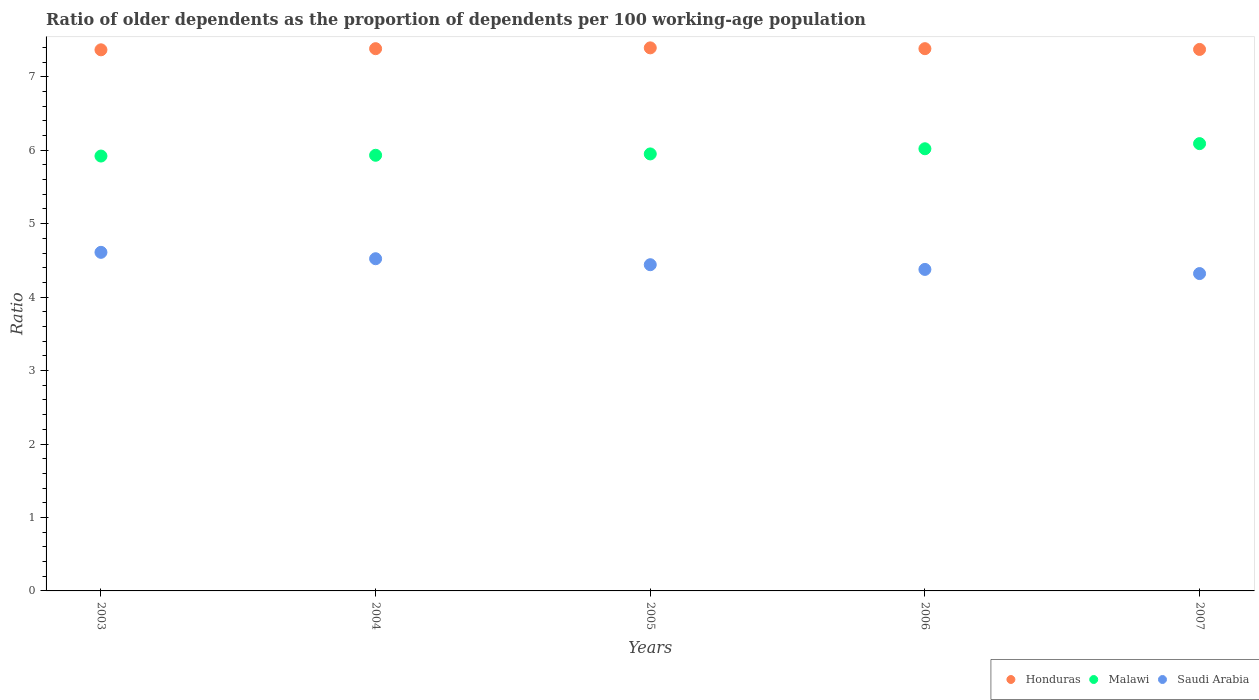What is the age dependency ratio(old) in Malawi in 2005?
Ensure brevity in your answer.  5.95. Across all years, what is the maximum age dependency ratio(old) in Honduras?
Give a very brief answer. 7.39. Across all years, what is the minimum age dependency ratio(old) in Saudi Arabia?
Keep it short and to the point. 4.32. In which year was the age dependency ratio(old) in Malawi minimum?
Your answer should be very brief. 2003. What is the total age dependency ratio(old) in Honduras in the graph?
Offer a very short reply. 36.9. What is the difference between the age dependency ratio(old) in Saudi Arabia in 2003 and that in 2004?
Offer a very short reply. 0.09. What is the difference between the age dependency ratio(old) in Malawi in 2004 and the age dependency ratio(old) in Saudi Arabia in 2007?
Keep it short and to the point. 1.61. What is the average age dependency ratio(old) in Malawi per year?
Keep it short and to the point. 5.98. In the year 2003, what is the difference between the age dependency ratio(old) in Malawi and age dependency ratio(old) in Honduras?
Your answer should be compact. -1.45. In how many years, is the age dependency ratio(old) in Saudi Arabia greater than 3.8?
Ensure brevity in your answer.  5. What is the ratio of the age dependency ratio(old) in Honduras in 2004 to that in 2007?
Your answer should be very brief. 1. Is the age dependency ratio(old) in Honduras in 2003 less than that in 2007?
Ensure brevity in your answer.  Yes. What is the difference between the highest and the second highest age dependency ratio(old) in Malawi?
Make the answer very short. 0.07. What is the difference between the highest and the lowest age dependency ratio(old) in Malawi?
Your answer should be very brief. 0.17. In how many years, is the age dependency ratio(old) in Malawi greater than the average age dependency ratio(old) in Malawi taken over all years?
Make the answer very short. 2. Is it the case that in every year, the sum of the age dependency ratio(old) in Saudi Arabia and age dependency ratio(old) in Honduras  is greater than the age dependency ratio(old) in Malawi?
Offer a very short reply. Yes. Does the age dependency ratio(old) in Honduras monotonically increase over the years?
Your answer should be very brief. No. How many years are there in the graph?
Provide a succinct answer. 5. Are the values on the major ticks of Y-axis written in scientific E-notation?
Provide a short and direct response. No. What is the title of the graph?
Provide a short and direct response. Ratio of older dependents as the proportion of dependents per 100 working-age population. What is the label or title of the Y-axis?
Offer a terse response. Ratio. What is the Ratio of Honduras in 2003?
Offer a very short reply. 7.37. What is the Ratio in Malawi in 2003?
Give a very brief answer. 5.92. What is the Ratio of Saudi Arabia in 2003?
Your response must be concise. 4.61. What is the Ratio in Honduras in 2004?
Provide a succinct answer. 7.38. What is the Ratio in Malawi in 2004?
Offer a very short reply. 5.93. What is the Ratio in Saudi Arabia in 2004?
Keep it short and to the point. 4.52. What is the Ratio of Honduras in 2005?
Your response must be concise. 7.39. What is the Ratio of Malawi in 2005?
Make the answer very short. 5.95. What is the Ratio in Saudi Arabia in 2005?
Keep it short and to the point. 4.44. What is the Ratio of Honduras in 2006?
Provide a short and direct response. 7.38. What is the Ratio of Malawi in 2006?
Offer a terse response. 6.02. What is the Ratio in Saudi Arabia in 2006?
Your response must be concise. 4.38. What is the Ratio in Honduras in 2007?
Offer a terse response. 7.37. What is the Ratio of Malawi in 2007?
Offer a very short reply. 6.09. What is the Ratio in Saudi Arabia in 2007?
Your answer should be very brief. 4.32. Across all years, what is the maximum Ratio in Honduras?
Make the answer very short. 7.39. Across all years, what is the maximum Ratio of Malawi?
Offer a very short reply. 6.09. Across all years, what is the maximum Ratio in Saudi Arabia?
Offer a terse response. 4.61. Across all years, what is the minimum Ratio of Honduras?
Ensure brevity in your answer.  7.37. Across all years, what is the minimum Ratio in Malawi?
Keep it short and to the point. 5.92. Across all years, what is the minimum Ratio of Saudi Arabia?
Your response must be concise. 4.32. What is the total Ratio of Honduras in the graph?
Provide a succinct answer. 36.9. What is the total Ratio of Malawi in the graph?
Your response must be concise. 29.91. What is the total Ratio of Saudi Arabia in the graph?
Make the answer very short. 22.27. What is the difference between the Ratio of Honduras in 2003 and that in 2004?
Your response must be concise. -0.02. What is the difference between the Ratio in Malawi in 2003 and that in 2004?
Provide a succinct answer. -0.01. What is the difference between the Ratio of Saudi Arabia in 2003 and that in 2004?
Offer a very short reply. 0.09. What is the difference between the Ratio in Honduras in 2003 and that in 2005?
Give a very brief answer. -0.03. What is the difference between the Ratio of Malawi in 2003 and that in 2005?
Offer a terse response. -0.03. What is the difference between the Ratio in Saudi Arabia in 2003 and that in 2005?
Keep it short and to the point. 0.17. What is the difference between the Ratio in Honduras in 2003 and that in 2006?
Offer a very short reply. -0.02. What is the difference between the Ratio of Malawi in 2003 and that in 2006?
Offer a terse response. -0.1. What is the difference between the Ratio in Saudi Arabia in 2003 and that in 2006?
Give a very brief answer. 0.23. What is the difference between the Ratio in Honduras in 2003 and that in 2007?
Make the answer very short. -0.01. What is the difference between the Ratio of Malawi in 2003 and that in 2007?
Provide a succinct answer. -0.17. What is the difference between the Ratio of Saudi Arabia in 2003 and that in 2007?
Your response must be concise. 0.29. What is the difference between the Ratio in Honduras in 2004 and that in 2005?
Ensure brevity in your answer.  -0.01. What is the difference between the Ratio of Malawi in 2004 and that in 2005?
Your answer should be very brief. -0.02. What is the difference between the Ratio of Saudi Arabia in 2004 and that in 2005?
Ensure brevity in your answer.  0.08. What is the difference between the Ratio of Honduras in 2004 and that in 2006?
Provide a short and direct response. -0. What is the difference between the Ratio in Malawi in 2004 and that in 2006?
Offer a terse response. -0.09. What is the difference between the Ratio of Saudi Arabia in 2004 and that in 2006?
Your answer should be very brief. 0.15. What is the difference between the Ratio of Honduras in 2004 and that in 2007?
Keep it short and to the point. 0.01. What is the difference between the Ratio of Malawi in 2004 and that in 2007?
Make the answer very short. -0.16. What is the difference between the Ratio in Saudi Arabia in 2004 and that in 2007?
Ensure brevity in your answer.  0.2. What is the difference between the Ratio of Honduras in 2005 and that in 2006?
Ensure brevity in your answer.  0.01. What is the difference between the Ratio of Malawi in 2005 and that in 2006?
Your answer should be compact. -0.07. What is the difference between the Ratio of Saudi Arabia in 2005 and that in 2006?
Make the answer very short. 0.06. What is the difference between the Ratio in Honduras in 2005 and that in 2007?
Offer a very short reply. 0.02. What is the difference between the Ratio in Malawi in 2005 and that in 2007?
Give a very brief answer. -0.14. What is the difference between the Ratio in Saudi Arabia in 2005 and that in 2007?
Your response must be concise. 0.12. What is the difference between the Ratio of Honduras in 2006 and that in 2007?
Your answer should be very brief. 0.01. What is the difference between the Ratio in Malawi in 2006 and that in 2007?
Your response must be concise. -0.07. What is the difference between the Ratio of Saudi Arabia in 2006 and that in 2007?
Provide a short and direct response. 0.06. What is the difference between the Ratio in Honduras in 2003 and the Ratio in Malawi in 2004?
Provide a succinct answer. 1.44. What is the difference between the Ratio of Honduras in 2003 and the Ratio of Saudi Arabia in 2004?
Provide a short and direct response. 2.84. What is the difference between the Ratio in Malawi in 2003 and the Ratio in Saudi Arabia in 2004?
Your answer should be compact. 1.4. What is the difference between the Ratio of Honduras in 2003 and the Ratio of Malawi in 2005?
Ensure brevity in your answer.  1.42. What is the difference between the Ratio of Honduras in 2003 and the Ratio of Saudi Arabia in 2005?
Offer a very short reply. 2.93. What is the difference between the Ratio in Malawi in 2003 and the Ratio in Saudi Arabia in 2005?
Your response must be concise. 1.48. What is the difference between the Ratio in Honduras in 2003 and the Ratio in Malawi in 2006?
Provide a succinct answer. 1.35. What is the difference between the Ratio in Honduras in 2003 and the Ratio in Saudi Arabia in 2006?
Your answer should be compact. 2.99. What is the difference between the Ratio in Malawi in 2003 and the Ratio in Saudi Arabia in 2006?
Your response must be concise. 1.54. What is the difference between the Ratio of Honduras in 2003 and the Ratio of Malawi in 2007?
Your response must be concise. 1.28. What is the difference between the Ratio of Honduras in 2003 and the Ratio of Saudi Arabia in 2007?
Provide a succinct answer. 3.05. What is the difference between the Ratio of Malawi in 2003 and the Ratio of Saudi Arabia in 2007?
Your answer should be compact. 1.6. What is the difference between the Ratio in Honduras in 2004 and the Ratio in Malawi in 2005?
Provide a succinct answer. 1.43. What is the difference between the Ratio of Honduras in 2004 and the Ratio of Saudi Arabia in 2005?
Give a very brief answer. 2.94. What is the difference between the Ratio of Malawi in 2004 and the Ratio of Saudi Arabia in 2005?
Give a very brief answer. 1.49. What is the difference between the Ratio of Honduras in 2004 and the Ratio of Malawi in 2006?
Keep it short and to the point. 1.36. What is the difference between the Ratio of Honduras in 2004 and the Ratio of Saudi Arabia in 2006?
Ensure brevity in your answer.  3.01. What is the difference between the Ratio in Malawi in 2004 and the Ratio in Saudi Arabia in 2006?
Offer a very short reply. 1.55. What is the difference between the Ratio of Honduras in 2004 and the Ratio of Malawi in 2007?
Give a very brief answer. 1.29. What is the difference between the Ratio in Honduras in 2004 and the Ratio in Saudi Arabia in 2007?
Your response must be concise. 3.06. What is the difference between the Ratio of Malawi in 2004 and the Ratio of Saudi Arabia in 2007?
Keep it short and to the point. 1.61. What is the difference between the Ratio of Honduras in 2005 and the Ratio of Malawi in 2006?
Give a very brief answer. 1.37. What is the difference between the Ratio of Honduras in 2005 and the Ratio of Saudi Arabia in 2006?
Give a very brief answer. 3.02. What is the difference between the Ratio in Malawi in 2005 and the Ratio in Saudi Arabia in 2006?
Ensure brevity in your answer.  1.57. What is the difference between the Ratio in Honduras in 2005 and the Ratio in Malawi in 2007?
Offer a very short reply. 1.3. What is the difference between the Ratio in Honduras in 2005 and the Ratio in Saudi Arabia in 2007?
Provide a succinct answer. 3.07. What is the difference between the Ratio of Malawi in 2005 and the Ratio of Saudi Arabia in 2007?
Ensure brevity in your answer.  1.63. What is the difference between the Ratio of Honduras in 2006 and the Ratio of Malawi in 2007?
Keep it short and to the point. 1.29. What is the difference between the Ratio of Honduras in 2006 and the Ratio of Saudi Arabia in 2007?
Make the answer very short. 3.06. What is the difference between the Ratio of Malawi in 2006 and the Ratio of Saudi Arabia in 2007?
Offer a terse response. 1.7. What is the average Ratio in Honduras per year?
Your response must be concise. 7.38. What is the average Ratio of Malawi per year?
Your answer should be compact. 5.98. What is the average Ratio of Saudi Arabia per year?
Offer a very short reply. 4.45. In the year 2003, what is the difference between the Ratio of Honduras and Ratio of Malawi?
Provide a succinct answer. 1.45. In the year 2003, what is the difference between the Ratio in Honduras and Ratio in Saudi Arabia?
Make the answer very short. 2.76. In the year 2003, what is the difference between the Ratio of Malawi and Ratio of Saudi Arabia?
Provide a short and direct response. 1.31. In the year 2004, what is the difference between the Ratio of Honduras and Ratio of Malawi?
Your response must be concise. 1.45. In the year 2004, what is the difference between the Ratio of Honduras and Ratio of Saudi Arabia?
Your answer should be compact. 2.86. In the year 2004, what is the difference between the Ratio of Malawi and Ratio of Saudi Arabia?
Give a very brief answer. 1.41. In the year 2005, what is the difference between the Ratio of Honduras and Ratio of Malawi?
Provide a short and direct response. 1.44. In the year 2005, what is the difference between the Ratio of Honduras and Ratio of Saudi Arabia?
Offer a terse response. 2.95. In the year 2005, what is the difference between the Ratio of Malawi and Ratio of Saudi Arabia?
Ensure brevity in your answer.  1.51. In the year 2006, what is the difference between the Ratio of Honduras and Ratio of Malawi?
Give a very brief answer. 1.36. In the year 2006, what is the difference between the Ratio in Honduras and Ratio in Saudi Arabia?
Provide a succinct answer. 3.01. In the year 2006, what is the difference between the Ratio of Malawi and Ratio of Saudi Arabia?
Provide a succinct answer. 1.64. In the year 2007, what is the difference between the Ratio of Honduras and Ratio of Malawi?
Offer a very short reply. 1.28. In the year 2007, what is the difference between the Ratio of Honduras and Ratio of Saudi Arabia?
Your response must be concise. 3.05. In the year 2007, what is the difference between the Ratio of Malawi and Ratio of Saudi Arabia?
Offer a very short reply. 1.77. What is the ratio of the Ratio of Honduras in 2003 to that in 2004?
Keep it short and to the point. 1. What is the ratio of the Ratio of Malawi in 2003 to that in 2004?
Provide a succinct answer. 1. What is the ratio of the Ratio of Saudi Arabia in 2003 to that in 2004?
Provide a succinct answer. 1.02. What is the ratio of the Ratio in Saudi Arabia in 2003 to that in 2005?
Ensure brevity in your answer.  1.04. What is the ratio of the Ratio of Malawi in 2003 to that in 2006?
Keep it short and to the point. 0.98. What is the ratio of the Ratio in Saudi Arabia in 2003 to that in 2006?
Provide a succinct answer. 1.05. What is the ratio of the Ratio of Malawi in 2003 to that in 2007?
Provide a succinct answer. 0.97. What is the ratio of the Ratio in Saudi Arabia in 2003 to that in 2007?
Provide a short and direct response. 1.07. What is the ratio of the Ratio of Malawi in 2004 to that in 2005?
Your answer should be compact. 1. What is the ratio of the Ratio of Saudi Arabia in 2004 to that in 2005?
Provide a short and direct response. 1.02. What is the ratio of the Ratio of Honduras in 2004 to that in 2006?
Provide a succinct answer. 1. What is the ratio of the Ratio of Honduras in 2004 to that in 2007?
Give a very brief answer. 1. What is the ratio of the Ratio of Saudi Arabia in 2004 to that in 2007?
Give a very brief answer. 1.05. What is the ratio of the Ratio in Malawi in 2005 to that in 2006?
Offer a terse response. 0.99. What is the ratio of the Ratio in Saudi Arabia in 2005 to that in 2006?
Your response must be concise. 1.01. What is the ratio of the Ratio in Honduras in 2005 to that in 2007?
Your answer should be very brief. 1. What is the ratio of the Ratio of Malawi in 2005 to that in 2007?
Your answer should be very brief. 0.98. What is the ratio of the Ratio in Saudi Arabia in 2005 to that in 2007?
Your answer should be very brief. 1.03. What is the ratio of the Ratio of Saudi Arabia in 2006 to that in 2007?
Your response must be concise. 1.01. What is the difference between the highest and the second highest Ratio in Honduras?
Your response must be concise. 0.01. What is the difference between the highest and the second highest Ratio of Malawi?
Provide a short and direct response. 0.07. What is the difference between the highest and the second highest Ratio of Saudi Arabia?
Provide a succinct answer. 0.09. What is the difference between the highest and the lowest Ratio in Honduras?
Your answer should be very brief. 0.03. What is the difference between the highest and the lowest Ratio in Malawi?
Keep it short and to the point. 0.17. What is the difference between the highest and the lowest Ratio of Saudi Arabia?
Provide a succinct answer. 0.29. 